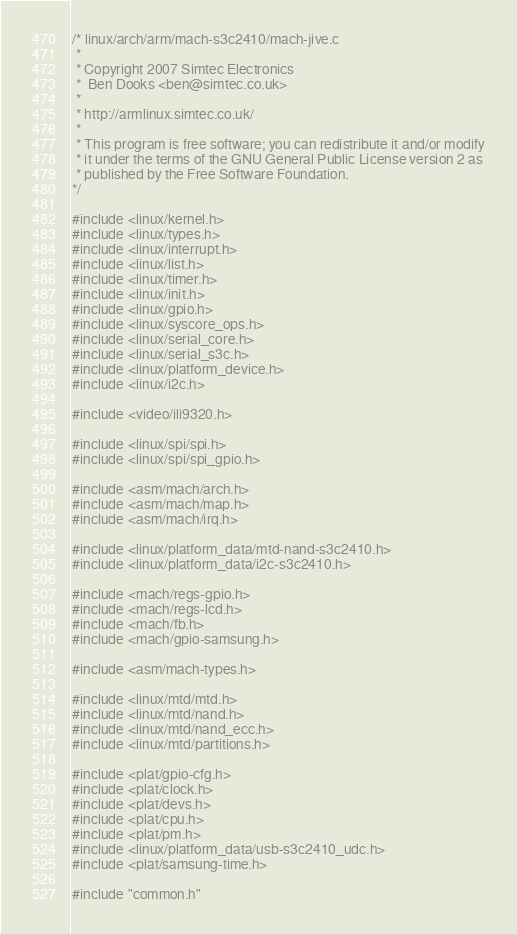<code> <loc_0><loc_0><loc_500><loc_500><_C_>/* linux/arch/arm/mach-s3c2410/mach-jive.c
 *
 * Copyright 2007 Simtec Electronics
 *	Ben Dooks <ben@simtec.co.uk>
 *
 * http://armlinux.simtec.co.uk/
 *
 * This program is free software; you can redistribute it and/or modify
 * it under the terms of the GNU General Public License version 2 as
 * published by the Free Software Foundation.
*/

#include <linux/kernel.h>
#include <linux/types.h>
#include <linux/interrupt.h>
#include <linux/list.h>
#include <linux/timer.h>
#include <linux/init.h>
#include <linux/gpio.h>
#include <linux/syscore_ops.h>
#include <linux/serial_core.h>
#include <linux/serial_s3c.h>
#include <linux/platform_device.h>
#include <linux/i2c.h>

#include <video/ili9320.h>

#include <linux/spi/spi.h>
#include <linux/spi/spi_gpio.h>

#include <asm/mach/arch.h>
#include <asm/mach/map.h>
#include <asm/mach/irq.h>

#include <linux/platform_data/mtd-nand-s3c2410.h>
#include <linux/platform_data/i2c-s3c2410.h>

#include <mach/regs-gpio.h>
#include <mach/regs-lcd.h>
#include <mach/fb.h>
#include <mach/gpio-samsung.h>

#include <asm/mach-types.h>

#include <linux/mtd/mtd.h>
#include <linux/mtd/nand.h>
#include <linux/mtd/nand_ecc.h>
#include <linux/mtd/partitions.h>

#include <plat/gpio-cfg.h>
#include <plat/clock.h>
#include <plat/devs.h>
#include <plat/cpu.h>
#include <plat/pm.h>
#include <linux/platform_data/usb-s3c2410_udc.h>
#include <plat/samsung-time.h>

#include "common.h"</code> 